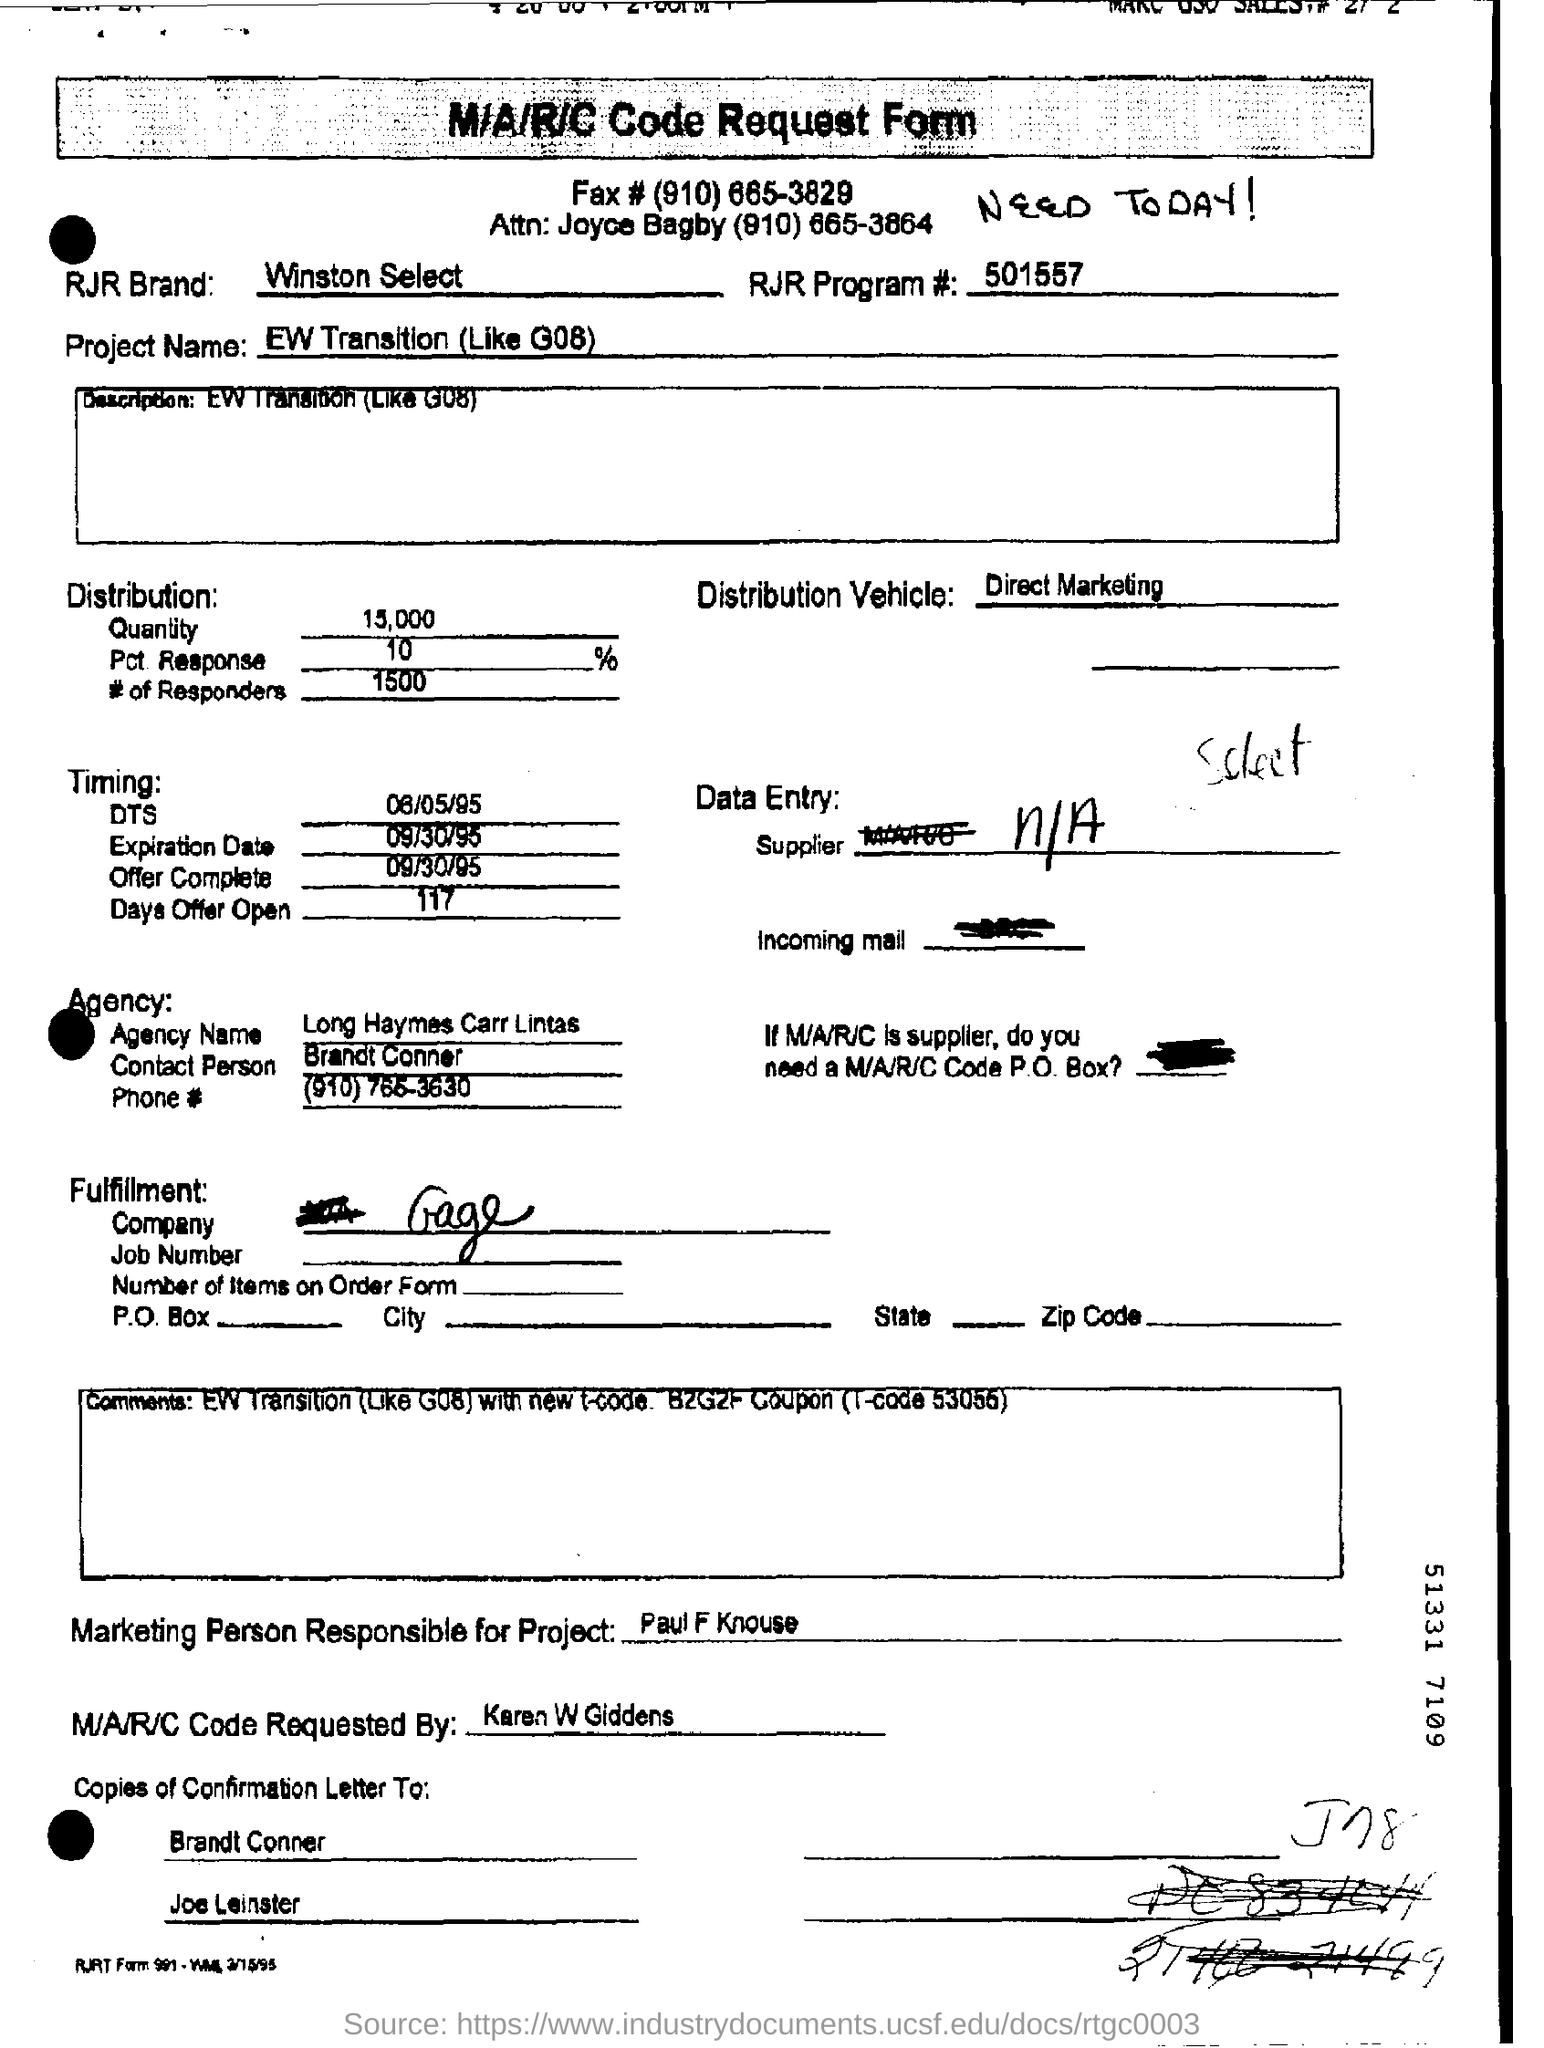Who is the Marketing Person responsible for Project?
Keep it short and to the point. Paul f knouse. Who requested M/A/R/C Code ?
Your answer should be compact. Karen W Giddens. What is  the RJR Brand?
Give a very brief answer. Winston select. What is the project name mentioned in the request form?
Give a very brief answer. Ew transition (like g08). How many days the offer is open?
Keep it short and to the point. 117. What is the Expiration date mentioned in the request form?
Your answer should be compact. 09/30/95. 